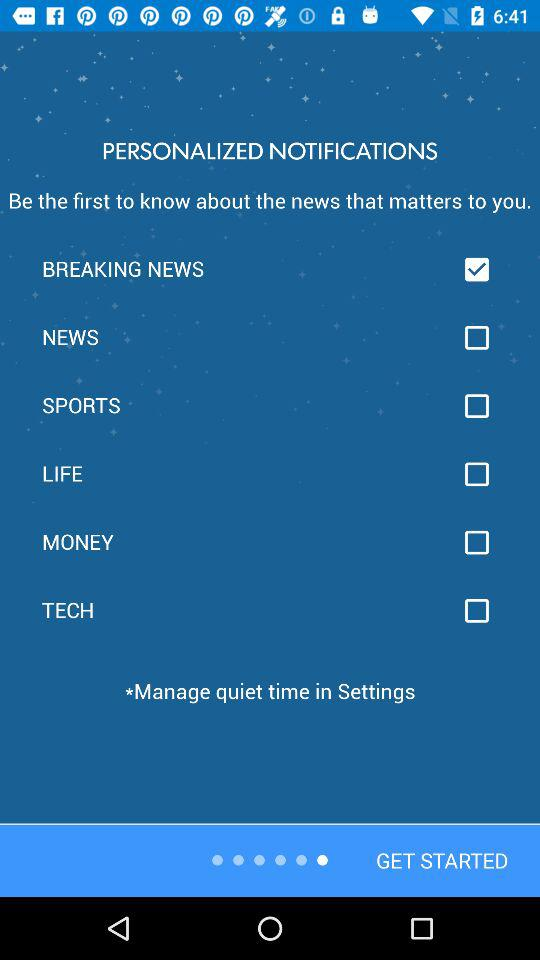How many categories are there to customize notifications?
Answer the question using a single word or phrase. 6 